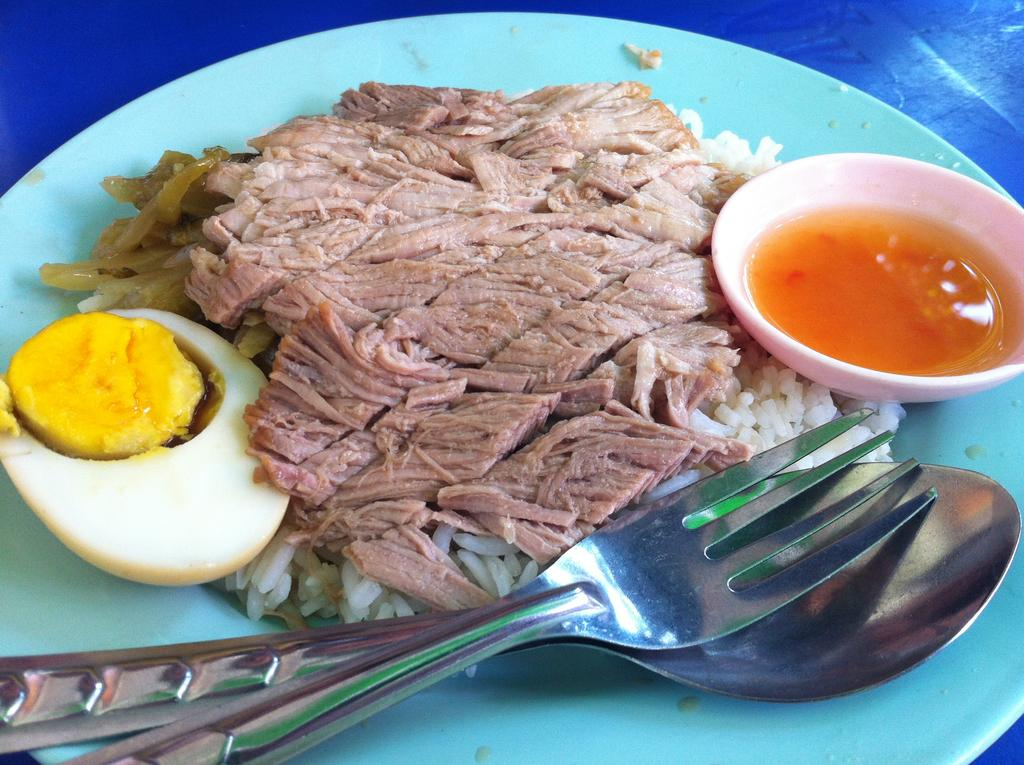What type of objects can be seen in the image? There are food items, a fork, and a spoon in the image. How are the fork and spoon positioned in the image? The fork and spoon are on a plate in the image. Where is the plate located in the image? The plate is on top of a table in the image. Can you tell me how many grapes are on the cheese in the image? There is no cheese or grapes present in the image. What is your brother doing in the image? There is no reference to a brother or any person in the image. 